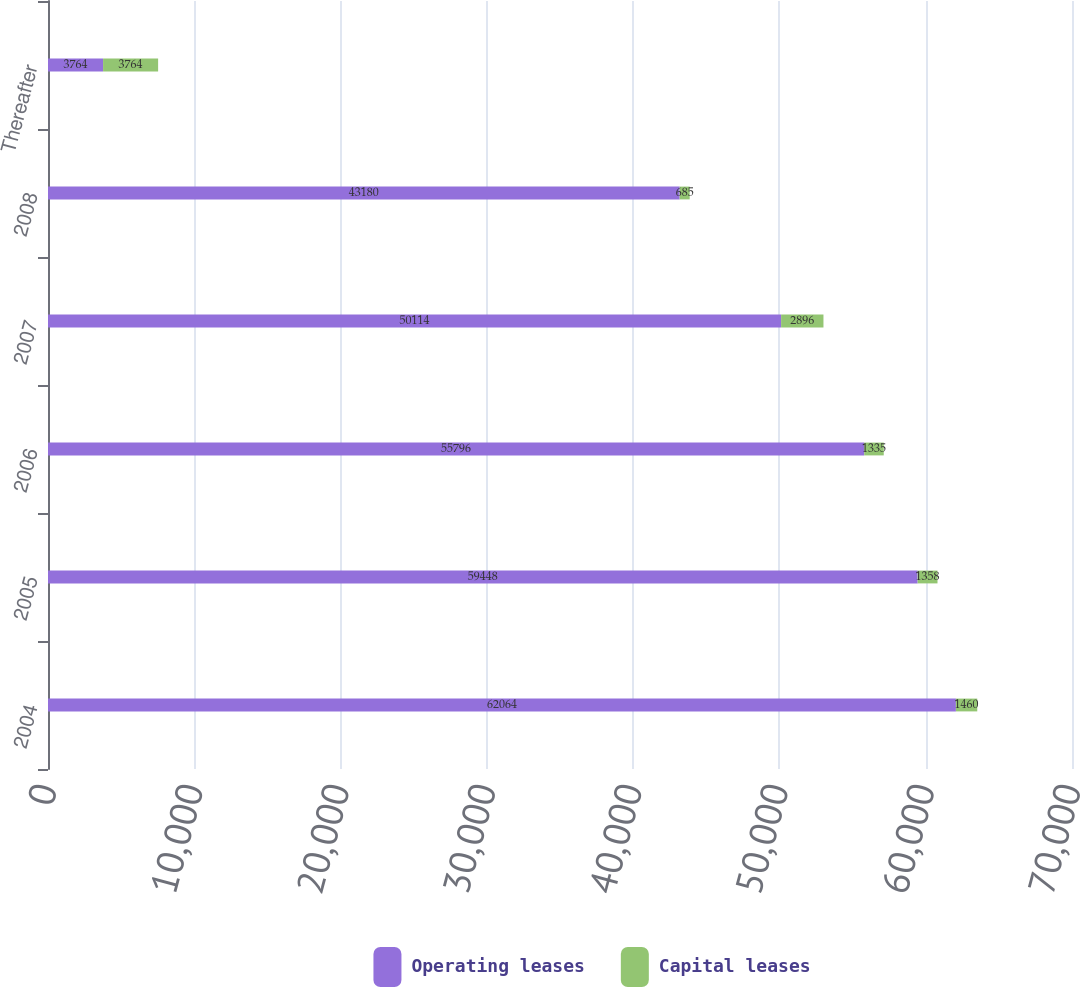Convert chart. <chart><loc_0><loc_0><loc_500><loc_500><stacked_bar_chart><ecel><fcel>2004<fcel>2005<fcel>2006<fcel>2007<fcel>2008<fcel>Thereafter<nl><fcel>Operating leases<fcel>62064<fcel>59448<fcel>55796<fcel>50114<fcel>43180<fcel>3764<nl><fcel>Capital leases<fcel>1460<fcel>1358<fcel>1335<fcel>2896<fcel>685<fcel>3764<nl></chart> 